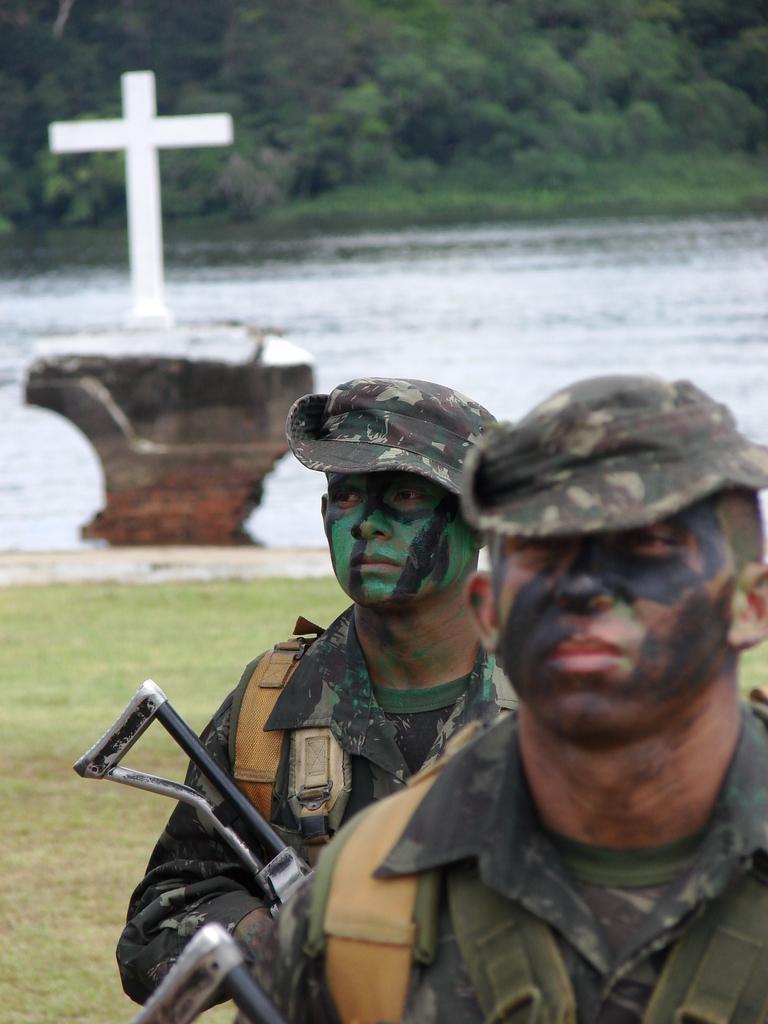Can you describe this image briefly? In this image we can see two men holding guns. On the backside we can see some grass, water, a cross and some trees. 